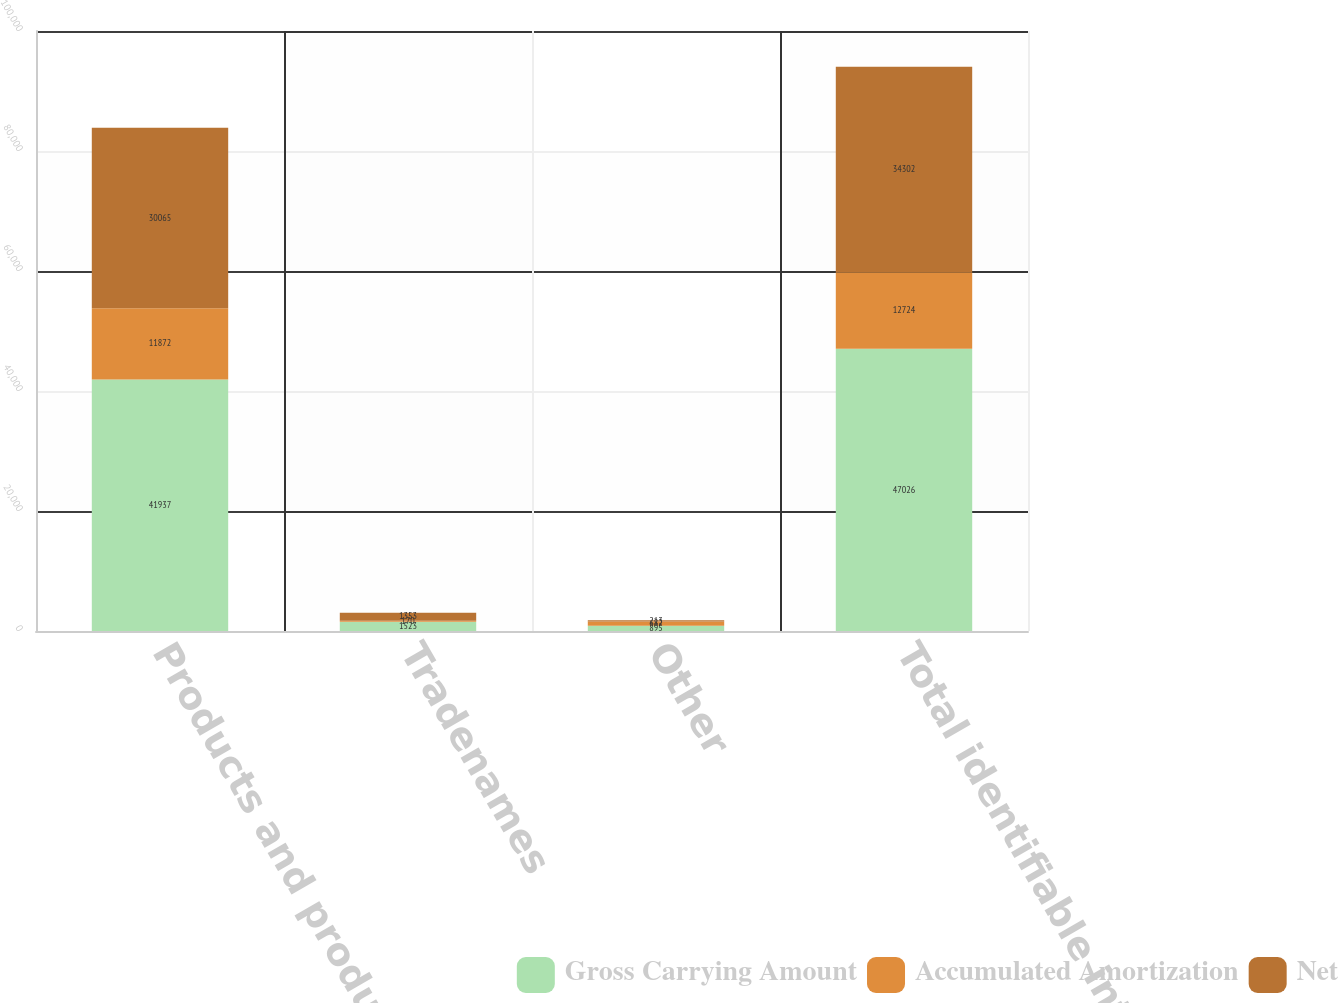Convert chart. <chart><loc_0><loc_0><loc_500><loc_500><stacked_bar_chart><ecel><fcel>Products and product rights<fcel>Tradenames<fcel>Other<fcel>Total identifiable intangible<nl><fcel>Gross Carrying Amount<fcel>41937<fcel>1523<fcel>895<fcel>47026<nl><fcel>Accumulated Amortization<fcel>11872<fcel>170<fcel>682<fcel>12724<nl><fcel>Net<fcel>30065<fcel>1353<fcel>213<fcel>34302<nl></chart> 